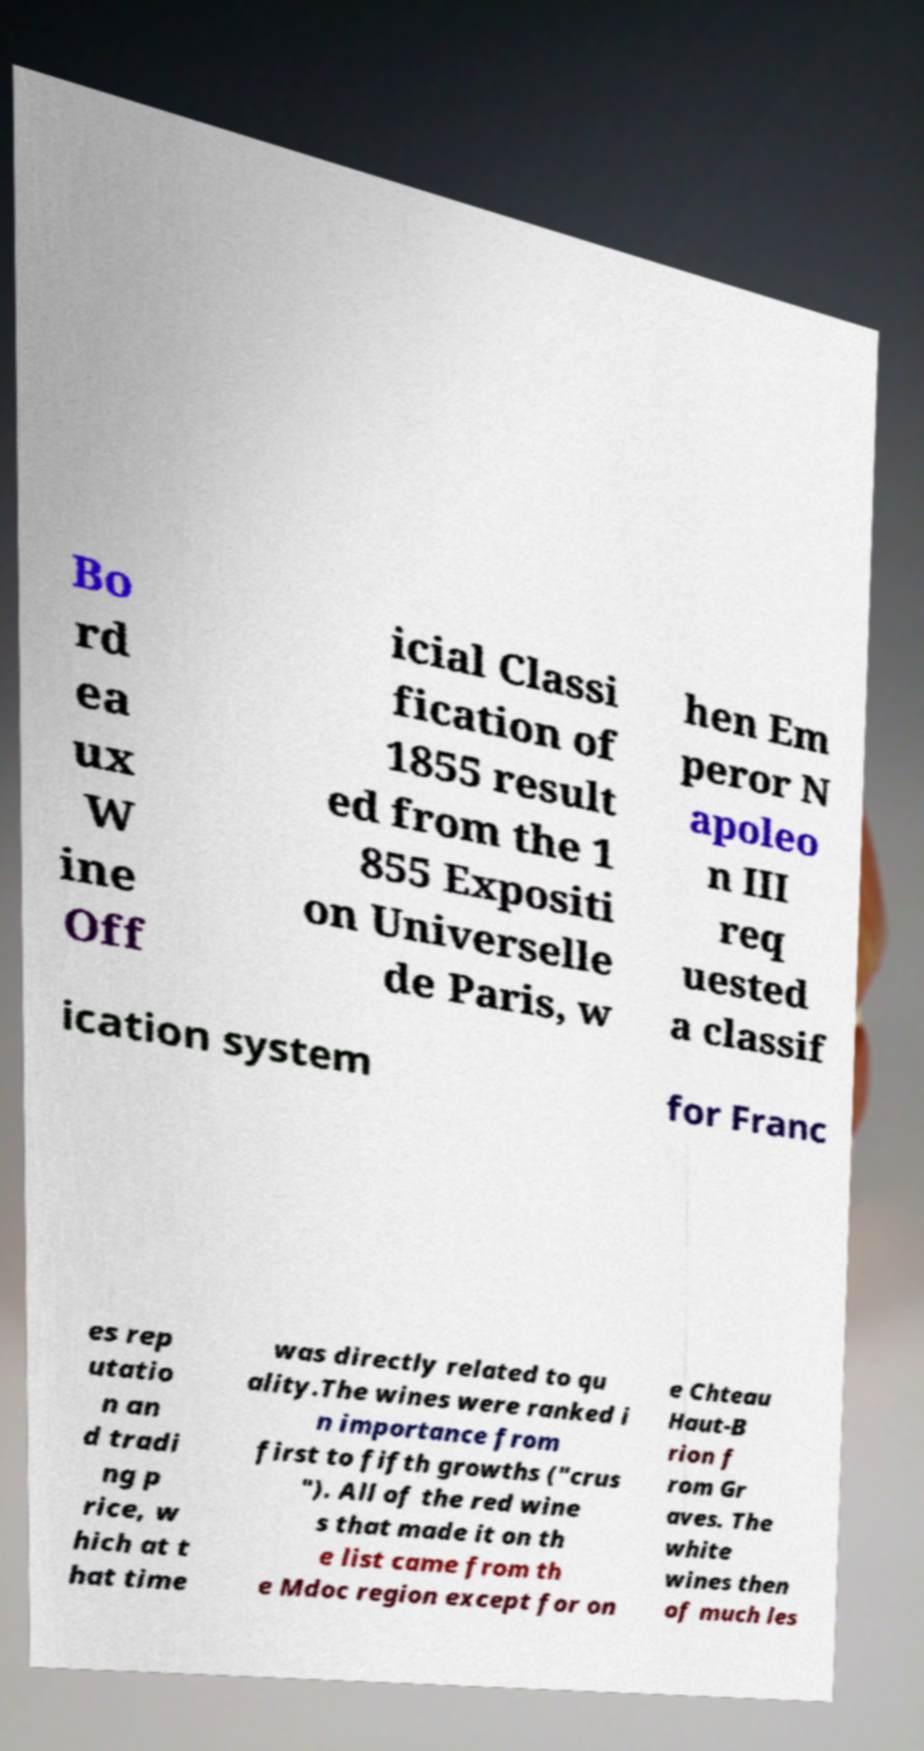There's text embedded in this image that I need extracted. Can you transcribe it verbatim? Bo rd ea ux W ine Off icial Classi fication of 1855 result ed from the 1 855 Expositi on Universelle de Paris, w hen Em peror N apoleo n III req uested a classif ication system for Franc es rep utatio n an d tradi ng p rice, w hich at t hat time was directly related to qu ality.The wines were ranked i n importance from first to fifth growths ("crus "). All of the red wine s that made it on th e list came from th e Mdoc region except for on e Chteau Haut-B rion f rom Gr aves. The white wines then of much les 